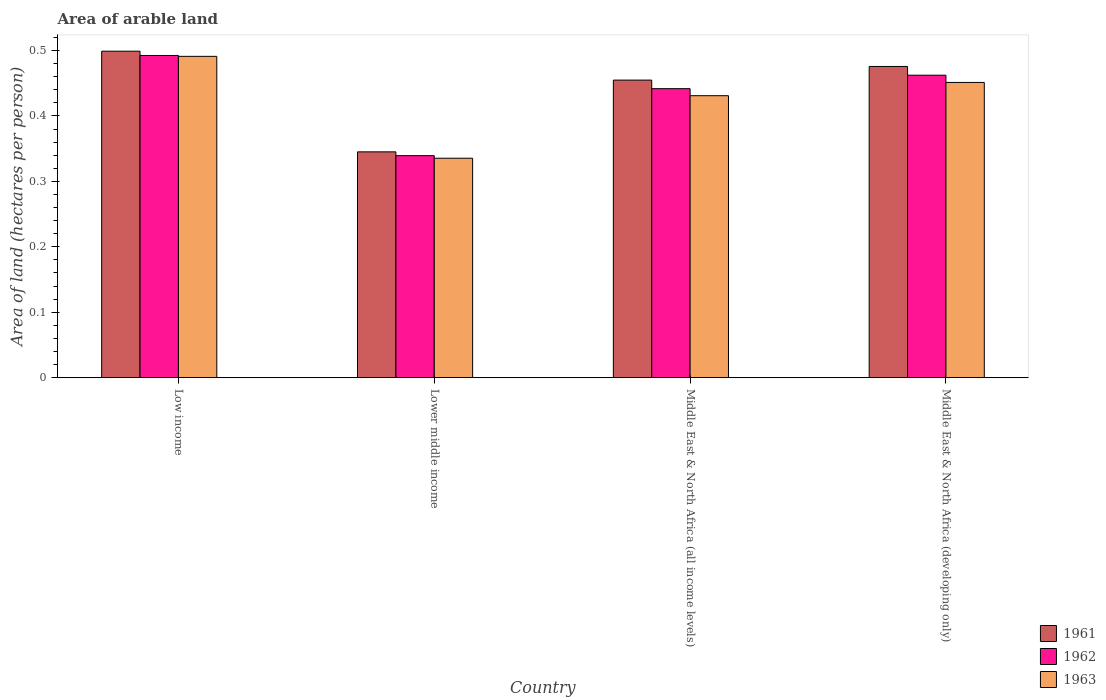Are the number of bars per tick equal to the number of legend labels?
Keep it short and to the point. Yes. Are the number of bars on each tick of the X-axis equal?
Your answer should be very brief. Yes. How many bars are there on the 3rd tick from the left?
Your answer should be very brief. 3. How many bars are there on the 3rd tick from the right?
Offer a terse response. 3. What is the label of the 3rd group of bars from the left?
Provide a short and direct response. Middle East & North Africa (all income levels). What is the total arable land in 1963 in Middle East & North Africa (developing only)?
Offer a terse response. 0.45. Across all countries, what is the maximum total arable land in 1961?
Provide a short and direct response. 0.5. Across all countries, what is the minimum total arable land in 1961?
Ensure brevity in your answer.  0.35. In which country was the total arable land in 1961 minimum?
Offer a very short reply. Lower middle income. What is the total total arable land in 1962 in the graph?
Provide a short and direct response. 1.74. What is the difference between the total arable land in 1962 in Low income and that in Middle East & North Africa (developing only)?
Make the answer very short. 0.03. What is the difference between the total arable land in 1961 in Middle East & North Africa (developing only) and the total arable land in 1962 in Low income?
Make the answer very short. -0.02. What is the average total arable land in 1961 per country?
Ensure brevity in your answer.  0.44. What is the difference between the total arable land of/in 1961 and total arable land of/in 1963 in Lower middle income?
Your answer should be compact. 0.01. What is the ratio of the total arable land in 1962 in Middle East & North Africa (all income levels) to that in Middle East & North Africa (developing only)?
Provide a succinct answer. 0.96. Is the difference between the total arable land in 1961 in Low income and Middle East & North Africa (developing only) greater than the difference between the total arable land in 1963 in Low income and Middle East & North Africa (developing only)?
Your response must be concise. No. What is the difference between the highest and the second highest total arable land in 1961?
Your response must be concise. 0.04. What is the difference between the highest and the lowest total arable land in 1962?
Keep it short and to the point. 0.15. In how many countries, is the total arable land in 1962 greater than the average total arable land in 1962 taken over all countries?
Give a very brief answer. 3. Is the sum of the total arable land in 1961 in Lower middle income and Middle East & North Africa (developing only) greater than the maximum total arable land in 1962 across all countries?
Your response must be concise. Yes. How many bars are there?
Your response must be concise. 12. How many countries are there in the graph?
Keep it short and to the point. 4. Does the graph contain any zero values?
Ensure brevity in your answer.  No. Where does the legend appear in the graph?
Give a very brief answer. Bottom right. How many legend labels are there?
Offer a very short reply. 3. How are the legend labels stacked?
Give a very brief answer. Vertical. What is the title of the graph?
Provide a succinct answer. Area of arable land. What is the label or title of the X-axis?
Provide a short and direct response. Country. What is the label or title of the Y-axis?
Offer a terse response. Area of land (hectares per person). What is the Area of land (hectares per person) in 1961 in Low income?
Ensure brevity in your answer.  0.5. What is the Area of land (hectares per person) in 1962 in Low income?
Ensure brevity in your answer.  0.49. What is the Area of land (hectares per person) of 1963 in Low income?
Make the answer very short. 0.49. What is the Area of land (hectares per person) in 1961 in Lower middle income?
Your response must be concise. 0.35. What is the Area of land (hectares per person) in 1962 in Lower middle income?
Give a very brief answer. 0.34. What is the Area of land (hectares per person) of 1963 in Lower middle income?
Your answer should be compact. 0.34. What is the Area of land (hectares per person) of 1961 in Middle East & North Africa (all income levels)?
Offer a terse response. 0.45. What is the Area of land (hectares per person) of 1962 in Middle East & North Africa (all income levels)?
Offer a terse response. 0.44. What is the Area of land (hectares per person) in 1963 in Middle East & North Africa (all income levels)?
Your answer should be very brief. 0.43. What is the Area of land (hectares per person) in 1961 in Middle East & North Africa (developing only)?
Provide a short and direct response. 0.48. What is the Area of land (hectares per person) of 1962 in Middle East & North Africa (developing only)?
Give a very brief answer. 0.46. What is the Area of land (hectares per person) in 1963 in Middle East & North Africa (developing only)?
Your answer should be compact. 0.45. Across all countries, what is the maximum Area of land (hectares per person) in 1961?
Your answer should be very brief. 0.5. Across all countries, what is the maximum Area of land (hectares per person) of 1962?
Make the answer very short. 0.49. Across all countries, what is the maximum Area of land (hectares per person) of 1963?
Your response must be concise. 0.49. Across all countries, what is the minimum Area of land (hectares per person) in 1961?
Ensure brevity in your answer.  0.35. Across all countries, what is the minimum Area of land (hectares per person) in 1962?
Keep it short and to the point. 0.34. Across all countries, what is the minimum Area of land (hectares per person) of 1963?
Your answer should be compact. 0.34. What is the total Area of land (hectares per person) of 1961 in the graph?
Keep it short and to the point. 1.77. What is the total Area of land (hectares per person) of 1962 in the graph?
Your answer should be compact. 1.74. What is the total Area of land (hectares per person) of 1963 in the graph?
Provide a succinct answer. 1.71. What is the difference between the Area of land (hectares per person) in 1961 in Low income and that in Lower middle income?
Your answer should be compact. 0.15. What is the difference between the Area of land (hectares per person) in 1962 in Low income and that in Lower middle income?
Ensure brevity in your answer.  0.15. What is the difference between the Area of land (hectares per person) of 1963 in Low income and that in Lower middle income?
Keep it short and to the point. 0.16. What is the difference between the Area of land (hectares per person) of 1961 in Low income and that in Middle East & North Africa (all income levels)?
Give a very brief answer. 0.04. What is the difference between the Area of land (hectares per person) of 1962 in Low income and that in Middle East & North Africa (all income levels)?
Your response must be concise. 0.05. What is the difference between the Area of land (hectares per person) of 1963 in Low income and that in Middle East & North Africa (all income levels)?
Your answer should be very brief. 0.06. What is the difference between the Area of land (hectares per person) in 1961 in Low income and that in Middle East & North Africa (developing only)?
Your answer should be very brief. 0.02. What is the difference between the Area of land (hectares per person) of 1962 in Low income and that in Middle East & North Africa (developing only)?
Ensure brevity in your answer.  0.03. What is the difference between the Area of land (hectares per person) of 1963 in Low income and that in Middle East & North Africa (developing only)?
Your response must be concise. 0.04. What is the difference between the Area of land (hectares per person) in 1961 in Lower middle income and that in Middle East & North Africa (all income levels)?
Provide a succinct answer. -0.11. What is the difference between the Area of land (hectares per person) of 1962 in Lower middle income and that in Middle East & North Africa (all income levels)?
Make the answer very short. -0.1. What is the difference between the Area of land (hectares per person) of 1963 in Lower middle income and that in Middle East & North Africa (all income levels)?
Your answer should be very brief. -0.1. What is the difference between the Area of land (hectares per person) of 1961 in Lower middle income and that in Middle East & North Africa (developing only)?
Make the answer very short. -0.13. What is the difference between the Area of land (hectares per person) of 1962 in Lower middle income and that in Middle East & North Africa (developing only)?
Keep it short and to the point. -0.12. What is the difference between the Area of land (hectares per person) in 1963 in Lower middle income and that in Middle East & North Africa (developing only)?
Provide a succinct answer. -0.12. What is the difference between the Area of land (hectares per person) in 1961 in Middle East & North Africa (all income levels) and that in Middle East & North Africa (developing only)?
Your response must be concise. -0.02. What is the difference between the Area of land (hectares per person) in 1962 in Middle East & North Africa (all income levels) and that in Middle East & North Africa (developing only)?
Ensure brevity in your answer.  -0.02. What is the difference between the Area of land (hectares per person) in 1963 in Middle East & North Africa (all income levels) and that in Middle East & North Africa (developing only)?
Your answer should be very brief. -0.02. What is the difference between the Area of land (hectares per person) in 1961 in Low income and the Area of land (hectares per person) in 1962 in Lower middle income?
Ensure brevity in your answer.  0.16. What is the difference between the Area of land (hectares per person) of 1961 in Low income and the Area of land (hectares per person) of 1963 in Lower middle income?
Provide a short and direct response. 0.16. What is the difference between the Area of land (hectares per person) in 1962 in Low income and the Area of land (hectares per person) in 1963 in Lower middle income?
Offer a terse response. 0.16. What is the difference between the Area of land (hectares per person) in 1961 in Low income and the Area of land (hectares per person) in 1962 in Middle East & North Africa (all income levels)?
Your response must be concise. 0.06. What is the difference between the Area of land (hectares per person) in 1961 in Low income and the Area of land (hectares per person) in 1963 in Middle East & North Africa (all income levels)?
Make the answer very short. 0.07. What is the difference between the Area of land (hectares per person) of 1962 in Low income and the Area of land (hectares per person) of 1963 in Middle East & North Africa (all income levels)?
Give a very brief answer. 0.06. What is the difference between the Area of land (hectares per person) in 1961 in Low income and the Area of land (hectares per person) in 1962 in Middle East & North Africa (developing only)?
Keep it short and to the point. 0.04. What is the difference between the Area of land (hectares per person) of 1961 in Low income and the Area of land (hectares per person) of 1963 in Middle East & North Africa (developing only)?
Make the answer very short. 0.05. What is the difference between the Area of land (hectares per person) in 1962 in Low income and the Area of land (hectares per person) in 1963 in Middle East & North Africa (developing only)?
Your answer should be compact. 0.04. What is the difference between the Area of land (hectares per person) in 1961 in Lower middle income and the Area of land (hectares per person) in 1962 in Middle East & North Africa (all income levels)?
Provide a succinct answer. -0.1. What is the difference between the Area of land (hectares per person) in 1961 in Lower middle income and the Area of land (hectares per person) in 1963 in Middle East & North Africa (all income levels)?
Keep it short and to the point. -0.09. What is the difference between the Area of land (hectares per person) in 1962 in Lower middle income and the Area of land (hectares per person) in 1963 in Middle East & North Africa (all income levels)?
Your answer should be very brief. -0.09. What is the difference between the Area of land (hectares per person) of 1961 in Lower middle income and the Area of land (hectares per person) of 1962 in Middle East & North Africa (developing only)?
Offer a very short reply. -0.12. What is the difference between the Area of land (hectares per person) in 1961 in Lower middle income and the Area of land (hectares per person) in 1963 in Middle East & North Africa (developing only)?
Make the answer very short. -0.11. What is the difference between the Area of land (hectares per person) of 1962 in Lower middle income and the Area of land (hectares per person) of 1963 in Middle East & North Africa (developing only)?
Provide a succinct answer. -0.11. What is the difference between the Area of land (hectares per person) of 1961 in Middle East & North Africa (all income levels) and the Area of land (hectares per person) of 1962 in Middle East & North Africa (developing only)?
Offer a terse response. -0.01. What is the difference between the Area of land (hectares per person) in 1961 in Middle East & North Africa (all income levels) and the Area of land (hectares per person) in 1963 in Middle East & North Africa (developing only)?
Give a very brief answer. 0. What is the difference between the Area of land (hectares per person) in 1962 in Middle East & North Africa (all income levels) and the Area of land (hectares per person) in 1963 in Middle East & North Africa (developing only)?
Your response must be concise. -0.01. What is the average Area of land (hectares per person) of 1961 per country?
Provide a succinct answer. 0.44. What is the average Area of land (hectares per person) in 1962 per country?
Provide a succinct answer. 0.43. What is the average Area of land (hectares per person) of 1963 per country?
Provide a succinct answer. 0.43. What is the difference between the Area of land (hectares per person) of 1961 and Area of land (hectares per person) of 1962 in Low income?
Provide a succinct answer. 0.01. What is the difference between the Area of land (hectares per person) in 1961 and Area of land (hectares per person) in 1963 in Low income?
Give a very brief answer. 0.01. What is the difference between the Area of land (hectares per person) in 1962 and Area of land (hectares per person) in 1963 in Low income?
Provide a succinct answer. 0. What is the difference between the Area of land (hectares per person) of 1961 and Area of land (hectares per person) of 1962 in Lower middle income?
Your answer should be very brief. 0.01. What is the difference between the Area of land (hectares per person) of 1961 and Area of land (hectares per person) of 1963 in Lower middle income?
Give a very brief answer. 0.01. What is the difference between the Area of land (hectares per person) of 1962 and Area of land (hectares per person) of 1963 in Lower middle income?
Provide a succinct answer. 0. What is the difference between the Area of land (hectares per person) in 1961 and Area of land (hectares per person) in 1962 in Middle East & North Africa (all income levels)?
Give a very brief answer. 0.01. What is the difference between the Area of land (hectares per person) in 1961 and Area of land (hectares per person) in 1963 in Middle East & North Africa (all income levels)?
Offer a very short reply. 0.02. What is the difference between the Area of land (hectares per person) of 1962 and Area of land (hectares per person) of 1963 in Middle East & North Africa (all income levels)?
Give a very brief answer. 0.01. What is the difference between the Area of land (hectares per person) in 1961 and Area of land (hectares per person) in 1962 in Middle East & North Africa (developing only)?
Provide a succinct answer. 0.01. What is the difference between the Area of land (hectares per person) in 1961 and Area of land (hectares per person) in 1963 in Middle East & North Africa (developing only)?
Keep it short and to the point. 0.02. What is the difference between the Area of land (hectares per person) of 1962 and Area of land (hectares per person) of 1963 in Middle East & North Africa (developing only)?
Your answer should be compact. 0.01. What is the ratio of the Area of land (hectares per person) of 1961 in Low income to that in Lower middle income?
Provide a succinct answer. 1.45. What is the ratio of the Area of land (hectares per person) of 1962 in Low income to that in Lower middle income?
Ensure brevity in your answer.  1.45. What is the ratio of the Area of land (hectares per person) of 1963 in Low income to that in Lower middle income?
Your response must be concise. 1.46. What is the ratio of the Area of land (hectares per person) of 1961 in Low income to that in Middle East & North Africa (all income levels)?
Make the answer very short. 1.1. What is the ratio of the Area of land (hectares per person) in 1962 in Low income to that in Middle East & North Africa (all income levels)?
Ensure brevity in your answer.  1.11. What is the ratio of the Area of land (hectares per person) of 1963 in Low income to that in Middle East & North Africa (all income levels)?
Provide a succinct answer. 1.14. What is the ratio of the Area of land (hectares per person) of 1961 in Low income to that in Middle East & North Africa (developing only)?
Offer a terse response. 1.05. What is the ratio of the Area of land (hectares per person) of 1962 in Low income to that in Middle East & North Africa (developing only)?
Give a very brief answer. 1.07. What is the ratio of the Area of land (hectares per person) in 1963 in Low income to that in Middle East & North Africa (developing only)?
Your answer should be very brief. 1.09. What is the ratio of the Area of land (hectares per person) of 1961 in Lower middle income to that in Middle East & North Africa (all income levels)?
Make the answer very short. 0.76. What is the ratio of the Area of land (hectares per person) in 1962 in Lower middle income to that in Middle East & North Africa (all income levels)?
Give a very brief answer. 0.77. What is the ratio of the Area of land (hectares per person) in 1963 in Lower middle income to that in Middle East & North Africa (all income levels)?
Offer a terse response. 0.78. What is the ratio of the Area of land (hectares per person) in 1961 in Lower middle income to that in Middle East & North Africa (developing only)?
Your response must be concise. 0.73. What is the ratio of the Area of land (hectares per person) in 1962 in Lower middle income to that in Middle East & North Africa (developing only)?
Your answer should be compact. 0.73. What is the ratio of the Area of land (hectares per person) of 1963 in Lower middle income to that in Middle East & North Africa (developing only)?
Your response must be concise. 0.74. What is the ratio of the Area of land (hectares per person) of 1961 in Middle East & North Africa (all income levels) to that in Middle East & North Africa (developing only)?
Provide a succinct answer. 0.96. What is the ratio of the Area of land (hectares per person) in 1962 in Middle East & North Africa (all income levels) to that in Middle East & North Africa (developing only)?
Offer a very short reply. 0.96. What is the ratio of the Area of land (hectares per person) of 1963 in Middle East & North Africa (all income levels) to that in Middle East & North Africa (developing only)?
Keep it short and to the point. 0.96. What is the difference between the highest and the second highest Area of land (hectares per person) of 1961?
Your answer should be very brief. 0.02. What is the difference between the highest and the second highest Area of land (hectares per person) in 1962?
Your answer should be compact. 0.03. What is the difference between the highest and the second highest Area of land (hectares per person) in 1963?
Provide a succinct answer. 0.04. What is the difference between the highest and the lowest Area of land (hectares per person) in 1961?
Make the answer very short. 0.15. What is the difference between the highest and the lowest Area of land (hectares per person) in 1962?
Offer a very short reply. 0.15. What is the difference between the highest and the lowest Area of land (hectares per person) in 1963?
Give a very brief answer. 0.16. 